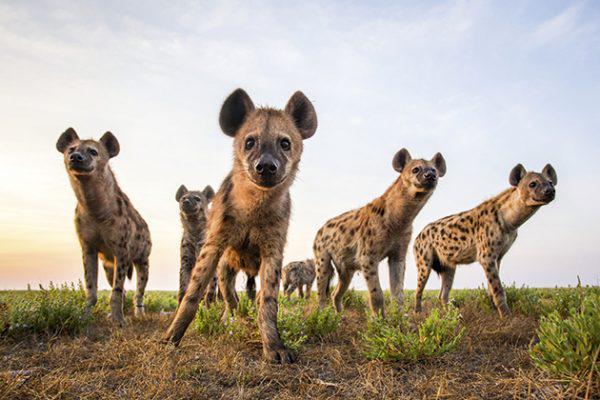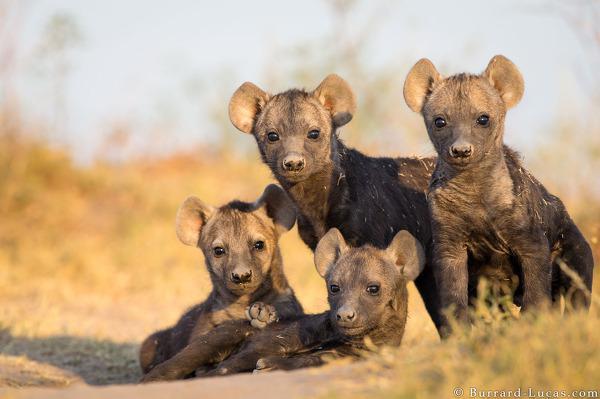The first image is the image on the left, the second image is the image on the right. Given the left and right images, does the statement "there is a hyena on brown grass with its mmouth open exposing the top and bottom teeth from the side view" hold true? Answer yes or no. No. The first image is the image on the left, the second image is the image on the right. Analyze the images presented: Is the assertion "One image shows exactly three hyenas standing with bodies turned leftward, some with heads craning to touch one of the others." valid? Answer yes or no. No. 